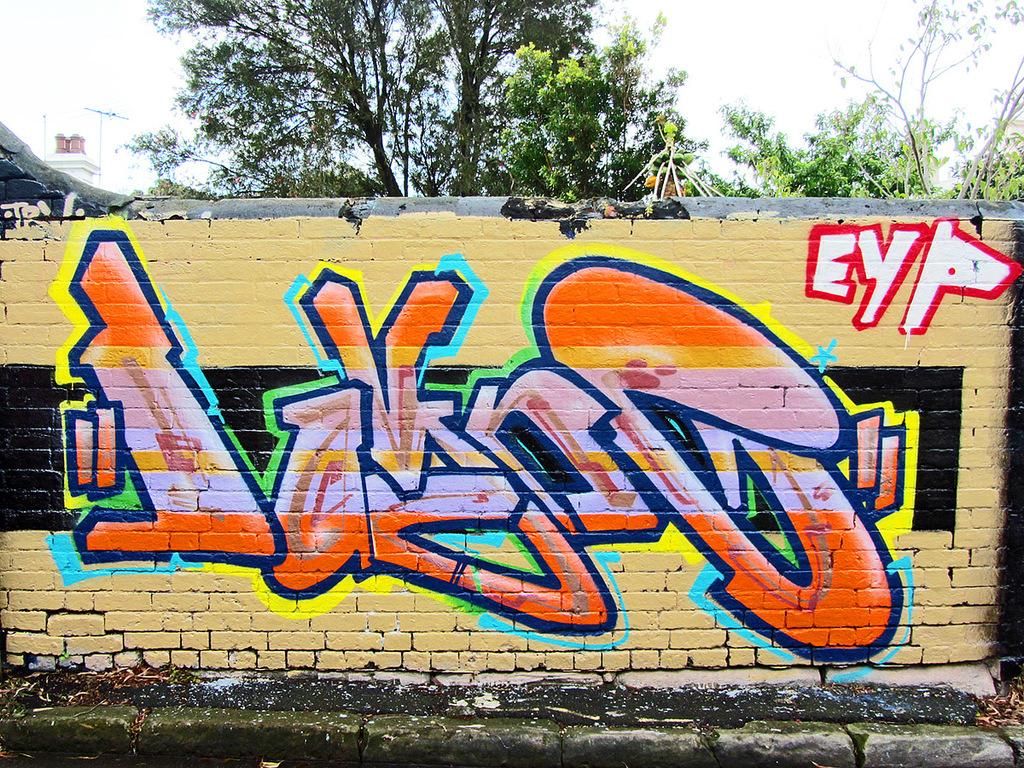What is on the wall in the image? There is a painting on the wall in the image. What can be seen in the background of the image? Branches and the sky are visible in the background of the image. Can you describe the object in the background of the image? There is an object in the background of the image, but its specific details are not clear from the provided facts. How does the ear in the image draw attention to itself? There is no ear present in the image; it features a painting on the wall, branches, and the sky in the background. 